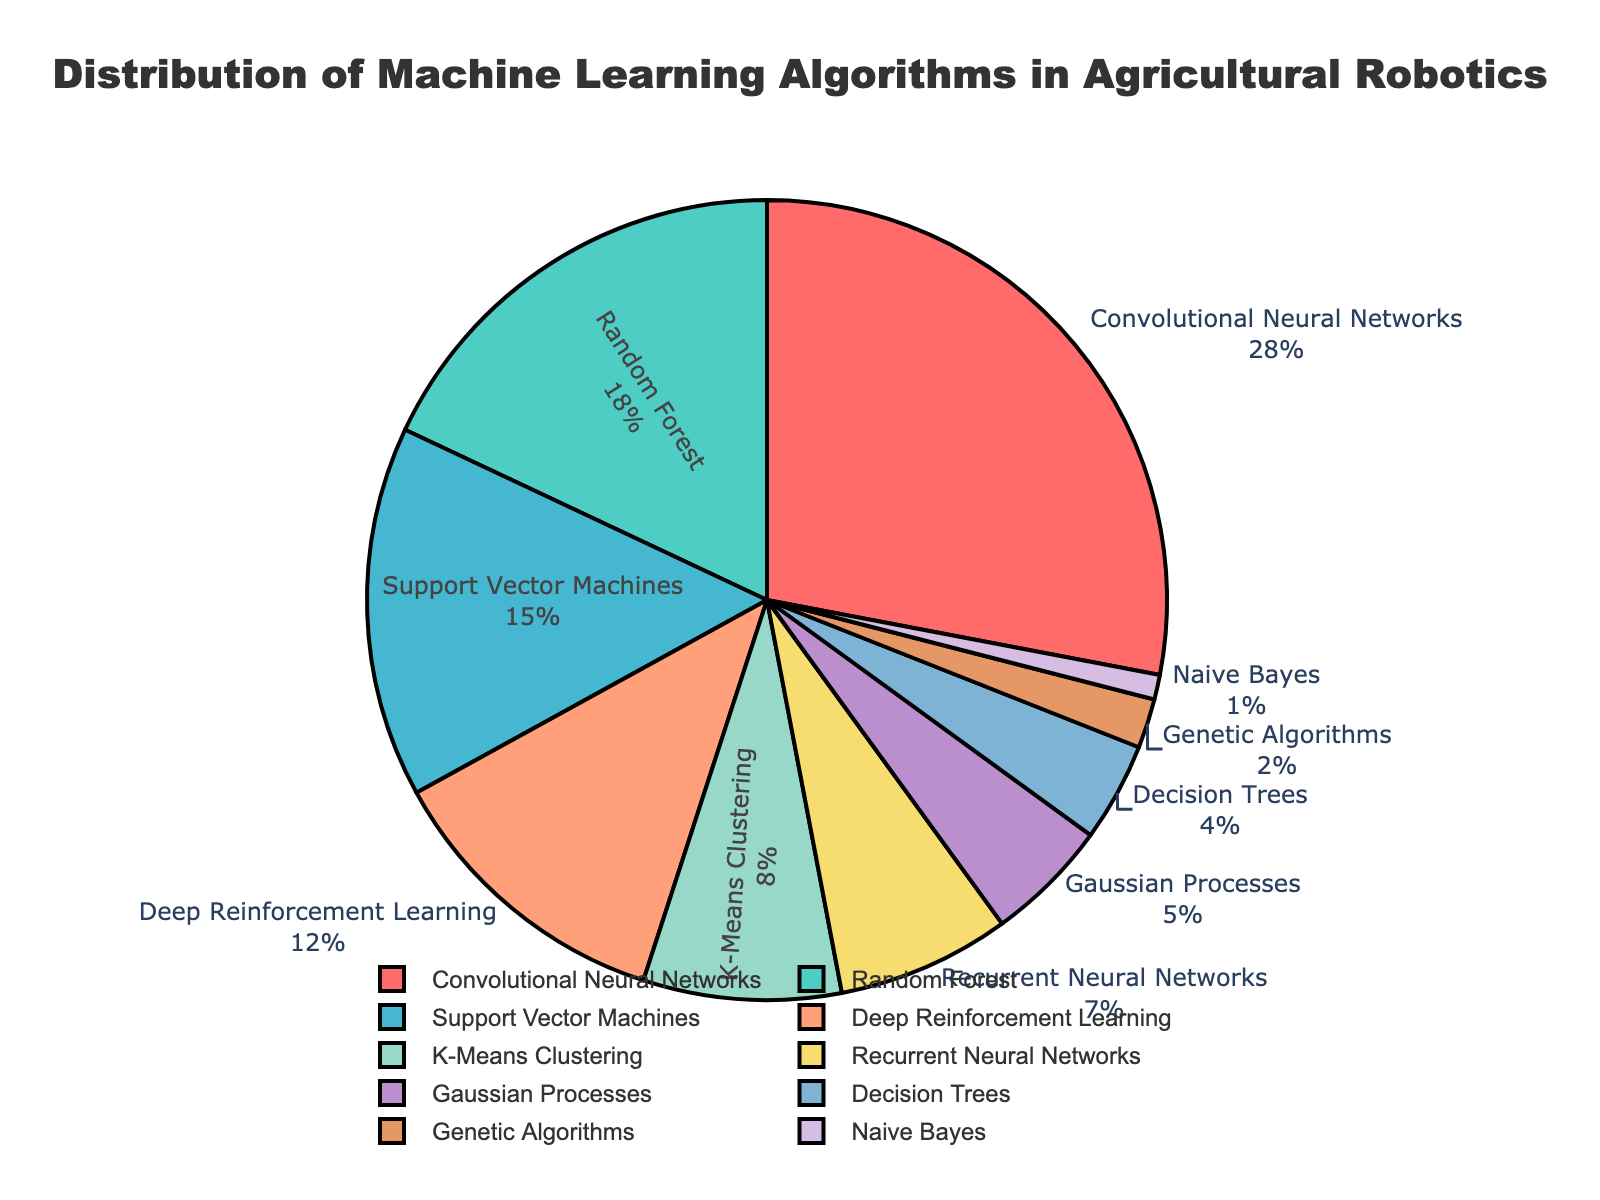Which machine learning algorithm has the highest percentage in the pie chart, and what is its percentage? Identify the largest section in the pie chart representing the highest percentage. The label and percentage of the largest portion are "Convolutional Neural Networks, 28%".
Answer: Convolutional Neural Networks, 28% Which two algorithms combined account for over 40% of the total distribution? Calculate the sum of the top two largest portions: 28% (Convolutional Neural Networks) and 18% (Random Forest), which together sum to 46%.
Answer: Convolutional Neural Networks and Random Forest What is the difference in percentage between Convolutional Neural Networks and Random Forest? Subtract the percentage of Random Forest (18%) from Convolutional Neural Networks (28%). The difference is: 28% - 18% = 10%.
Answer: 10% How many algorithms have a percentage of 5% or less? Identify the sections of the pie chart with labels indicating percentages of 5% or less: Gaussian Processes (5%), Decision Trees (4%), Genetic Algorithms (2%), Naive Bayes (1%). Count these sections.
Answer: 4 Which algorithm has the smallest percentage, and what is that percentage? Locate the smallest section of the pie chart. The label and percentage of the smallest portion are "Naive Bayes, 1%".
Answer: Naive Bayes, 1% What is the cumulative percentage of the algorithms with percentages less than 10%? Sum the percentages of the sections with less than 10%: K-Means Clustering (8%), Recurrent Neural Networks (7%), Gaussian Processes (5%), Decision Trees (4%), Genetic Algorithms (2%), Naive Bayes (1%). The cumulative percentage is 8% + 7% + 5% + 4% + 2% + 1% = 27%.
Answer: 27% Which algorithms have percentages that are more than the percentage of K-Means Clustering? Identify the sections with percentages higher than 8% (K-Means Clustering): Convolutional Neural Networks (28%), Random Forest (18%), Support Vector Machines (15%), Deep Reinforcement Learning (12%).
Answer: Convolutional Neural Networks, Random Forest, Support Vector Machines, Deep Reinforcement Learning What is the sum of the percentages of Support Vector Machines and Deep Reinforcement Learning? Add the percentages of Support Vector Machines (15%) and Deep Reinforcement Learning (12%). The sum is: 15% + 12% = 27%.
Answer: 27% Which algorithm has a portion colored in blue in the pie chart? Identify the color associated with each portion of the pie chart. The section colored in blue corresponds to "Convolutional Neural Networks".
Answer: Convolutional Neural Networks 